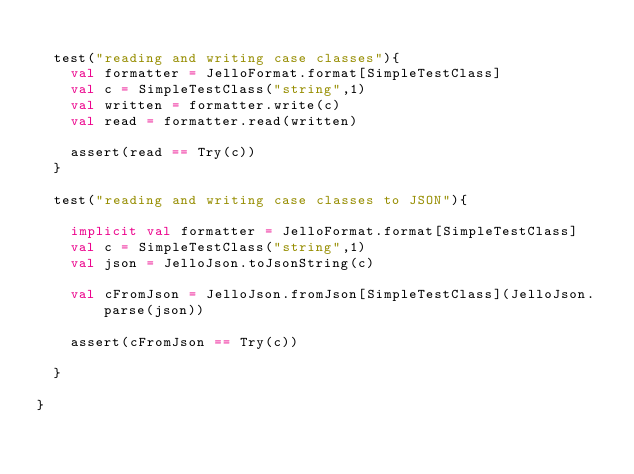<code> <loc_0><loc_0><loc_500><loc_500><_Scala_>
	test("reading and writing case classes"){
		val formatter = JelloFormat.format[SimpleTestClass]
		val c = SimpleTestClass("string",1)
		val written = formatter.write(c)
		val read = formatter.read(written)

		assert(read == Try(c))
	}

	test("reading and writing case classes to JSON"){

		implicit val formatter = JelloFormat.format[SimpleTestClass]
		val c = SimpleTestClass("string",1)
		val json = JelloJson.toJsonString(c)

		val cFromJson = JelloJson.fromJson[SimpleTestClass](JelloJson.parse(json))

		assert(cFromJson == Try(c))

	}

}</code> 